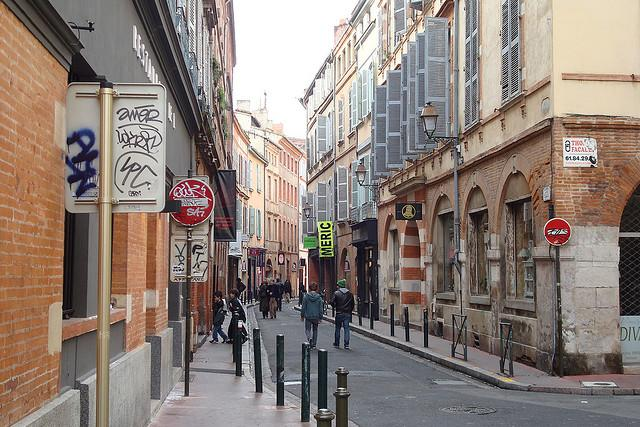What damage has been done in this street? Please explain your reasoning. graffiti. There is a lot of graffiti work up and down the street. 